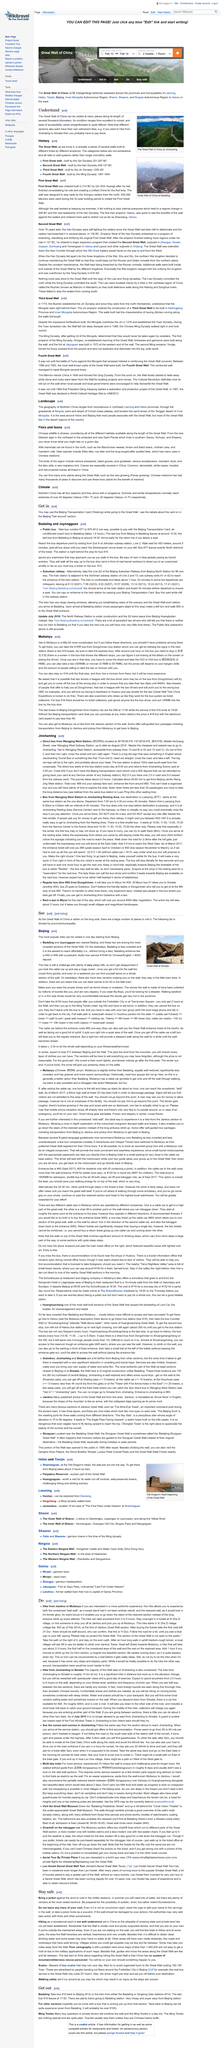Give some essential details in this illustration. The Great Wall of China, one of the most iconic landmarks in China, can be found in various provinces and municipalities including Liaoning, Hebei, Tiajin, Beijing, Inner Mongolia Autonomous region, Shanxi, Shaanxi, and Ningxia Autonomous Region to Gantsu in the west. The Chinese name for the Great Wall of China is Changcheng. The Great Wall of China can be visited at various locations including Tianjin, Beijing, and Hebei, each with their own admission fees for different sections. 